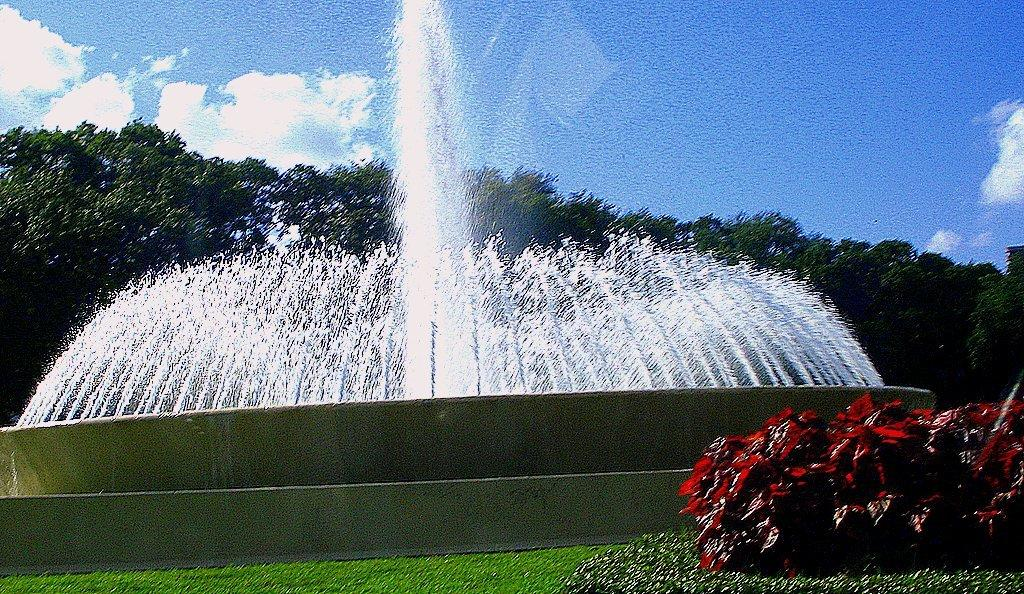What type of vegetation can be seen in the image? There are plants and trees visible in the image. Where is the grassland located in the image? The grassland is at the bottom side of the image. What is in the center of the image? There is a fountain in the center of the image. What can be seen in the background of the image? Trees and the sky are visible in the background of the image. How many pages are visible in the image? There are no pages present in the image; it features plants, grassland, a fountain, trees, and the sky. What type of bit is being used to interact with the fountain in the image? There is no bit present in the image, and the fountain is not being interacted with in any way. 